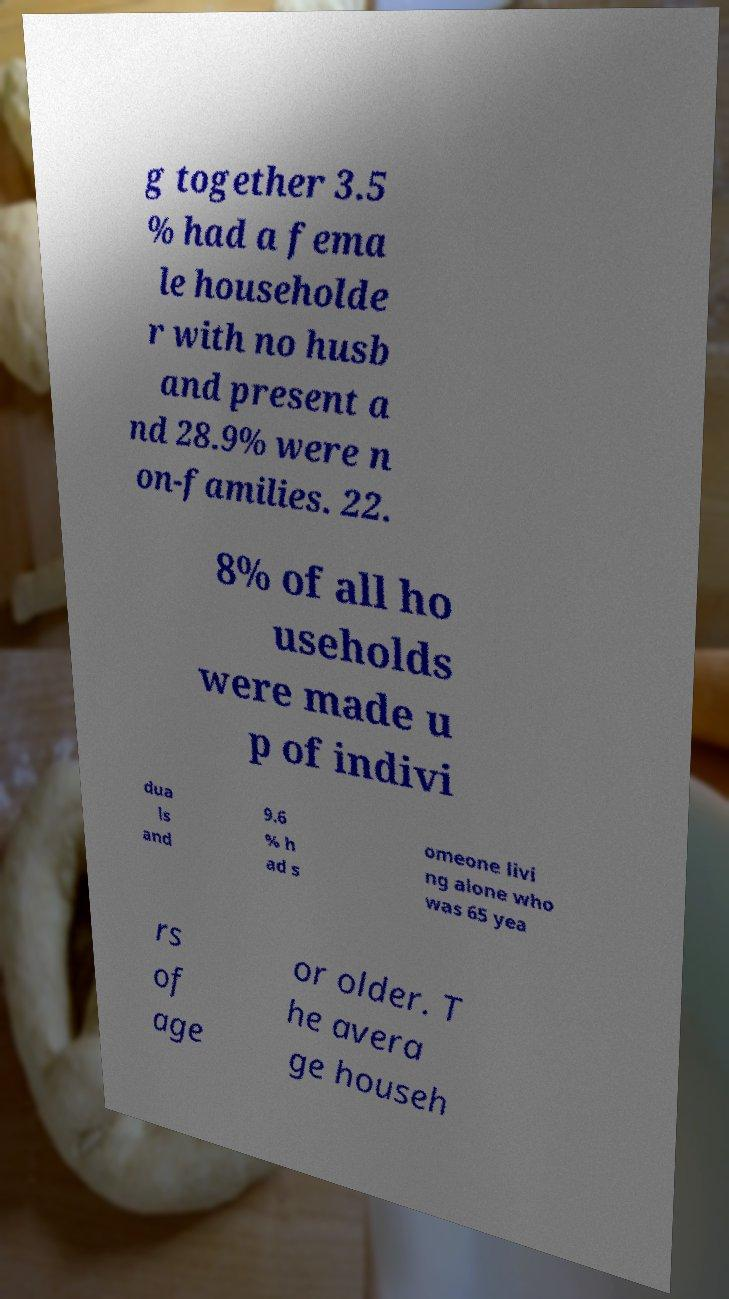Please read and relay the text visible in this image. What does it say? g together 3.5 % had a fema le householde r with no husb and present a nd 28.9% were n on-families. 22. 8% of all ho useholds were made u p of indivi dua ls and 9.6 % h ad s omeone livi ng alone who was 65 yea rs of age or older. T he avera ge househ 